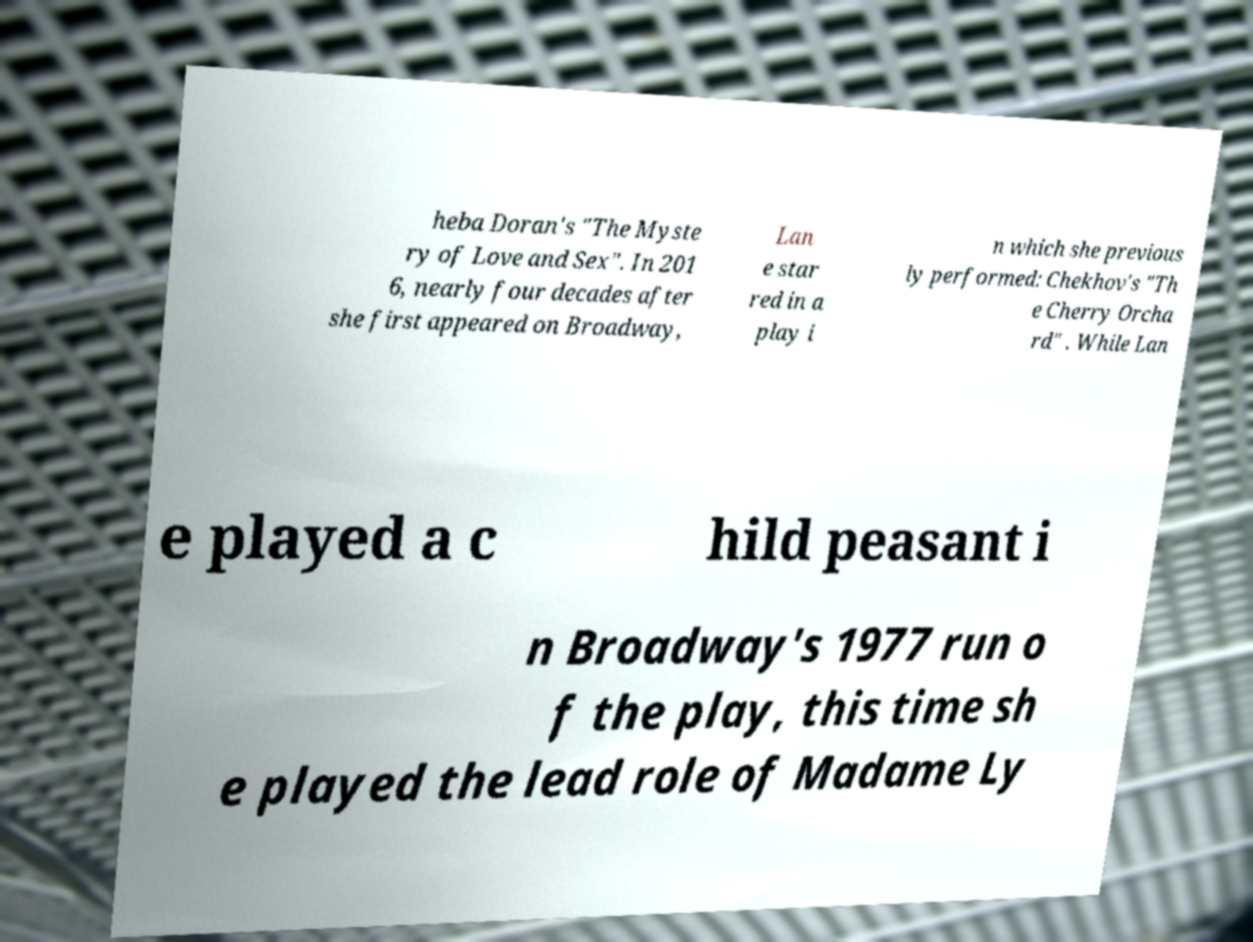Can you accurately transcribe the text from the provided image for me? heba Doran's "The Myste ry of Love and Sex". In 201 6, nearly four decades after she first appeared on Broadway, Lan e star red in a play i n which she previous ly performed: Chekhov's "Th e Cherry Orcha rd" . While Lan e played a c hild peasant i n Broadway's 1977 run o f the play, this time sh e played the lead role of Madame Ly 